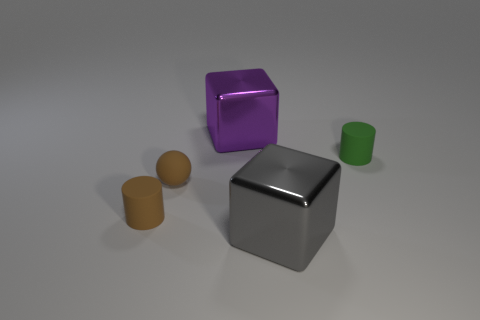There is a rubber thing that is right of the gray thing that is to the right of the metal block behind the large gray shiny object; what is its size?
Give a very brief answer. Small. Is the number of small green cylinders greater than the number of gray cylinders?
Offer a very short reply. Yes. Is the material of the big cube that is in front of the large purple cube the same as the ball?
Offer a very short reply. No. Is the number of large shiny things less than the number of brown matte cylinders?
Ensure brevity in your answer.  No. Are there any brown matte cylinders in front of the tiny cylinder that is left of the shiny thing that is right of the purple shiny object?
Offer a terse response. No. Do the small rubber object to the left of the small brown ball and the green rubber object have the same shape?
Your answer should be compact. Yes. Is the number of large purple cubes to the right of the gray cube greater than the number of purple metallic objects?
Provide a succinct answer. No. Do the object to the right of the gray thing and the small rubber ball have the same color?
Provide a short and direct response. No. Is there any other thing of the same color as the ball?
Offer a very short reply. Yes. There is a metal cube behind the rubber cylinder in front of the cylinder behind the small brown sphere; what color is it?
Offer a very short reply. Purple. 